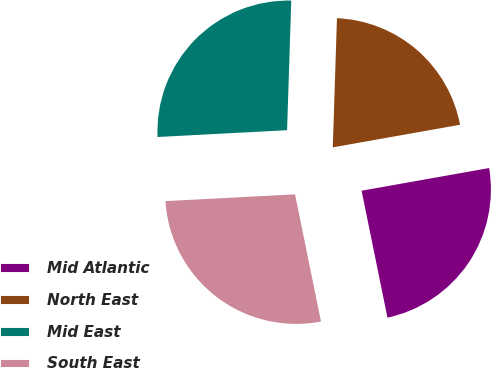Convert chart. <chart><loc_0><loc_0><loc_500><loc_500><pie_chart><fcel>Mid Atlantic<fcel>North East<fcel>Mid East<fcel>South East<nl><fcel>24.6%<fcel>21.69%<fcel>26.35%<fcel>27.37%<nl></chart> 